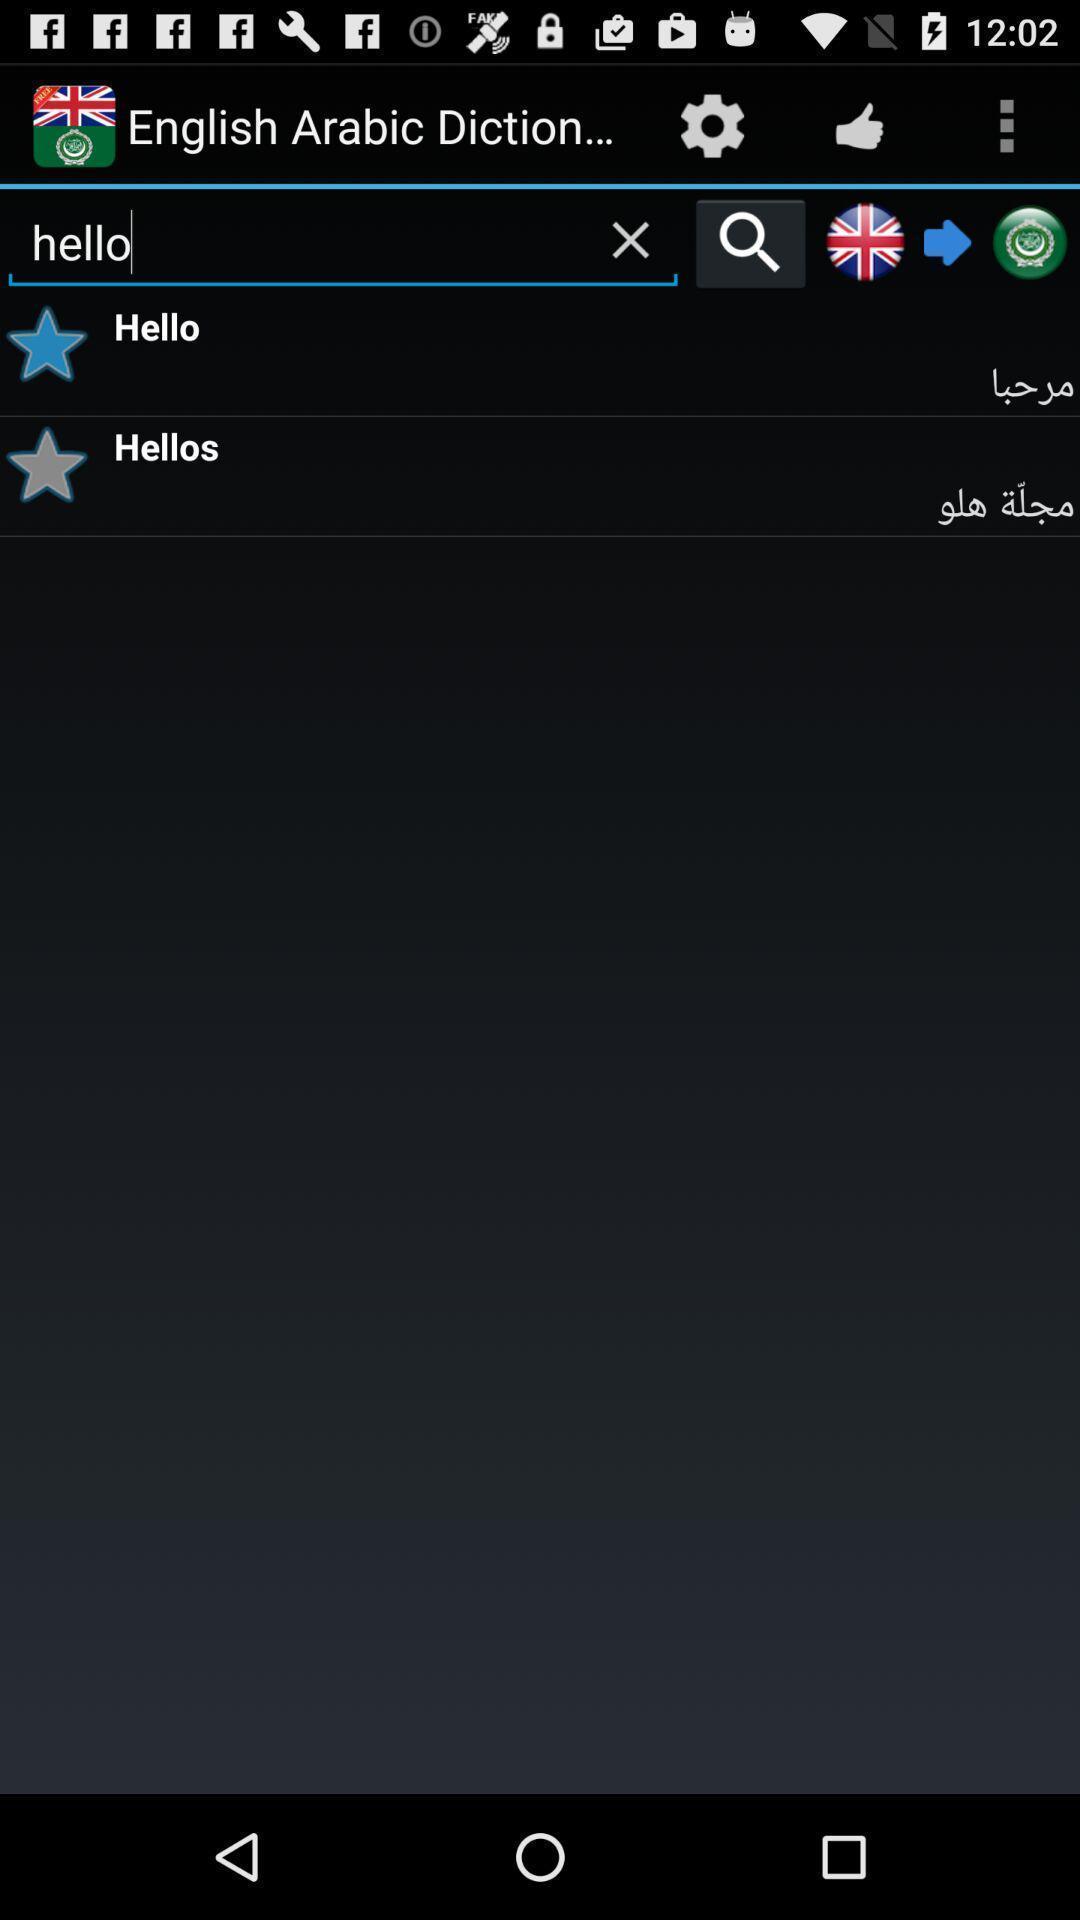Provide a textual representation of this image. Screen showing a dictionary in a device. 